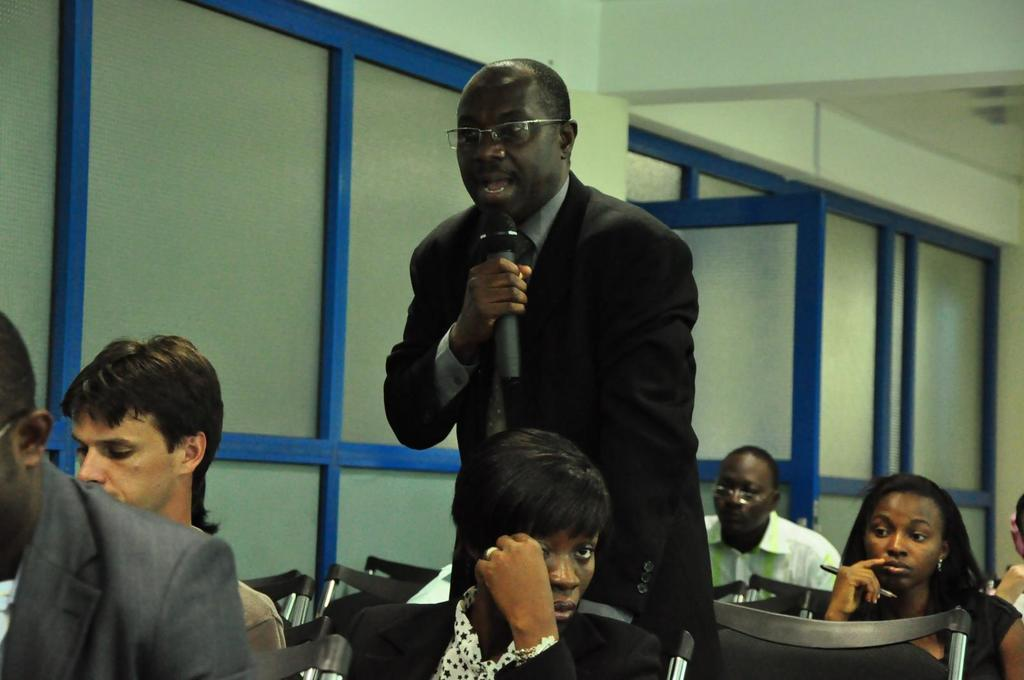What are the people in the image doing? The people in the image are sitting on chairs. What is the person standing doing? The person standing is holding a mic. Can you describe the structure in the background of the image? There is a wall with a door in the image. What type of hammer is being used by the person standing in the image? There is no hammer present in the image; the person standing is holding a mic. What kind of love is being expressed by the people sitting on chairs in the image? There is no indication of love being expressed in the image; the people are simply sitting on chairs. 